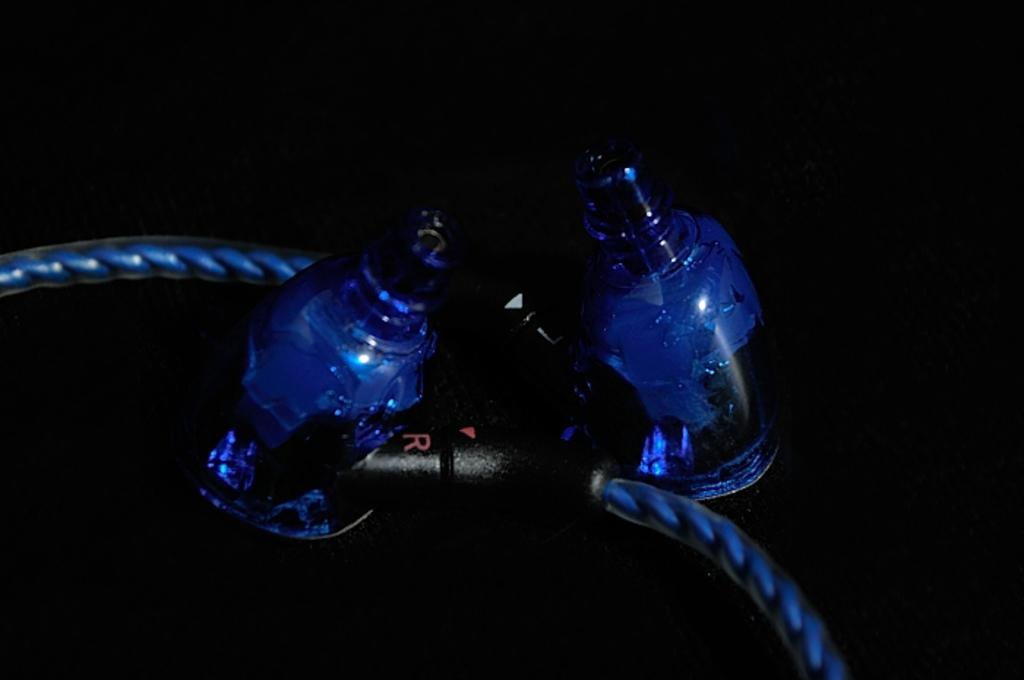<image>
Present a compact description of the photo's key features. Cables connect two plastic items and have a black piece with a R and L on either side. 